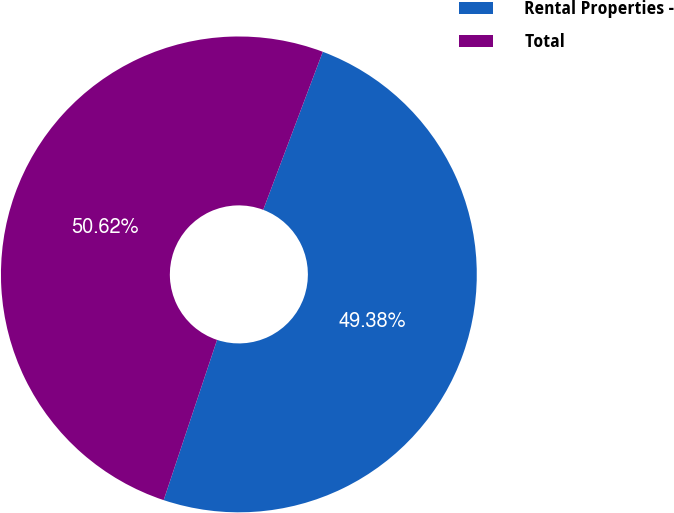Convert chart. <chart><loc_0><loc_0><loc_500><loc_500><pie_chart><fcel>Rental Properties -<fcel>Total<nl><fcel>49.38%<fcel>50.62%<nl></chart> 